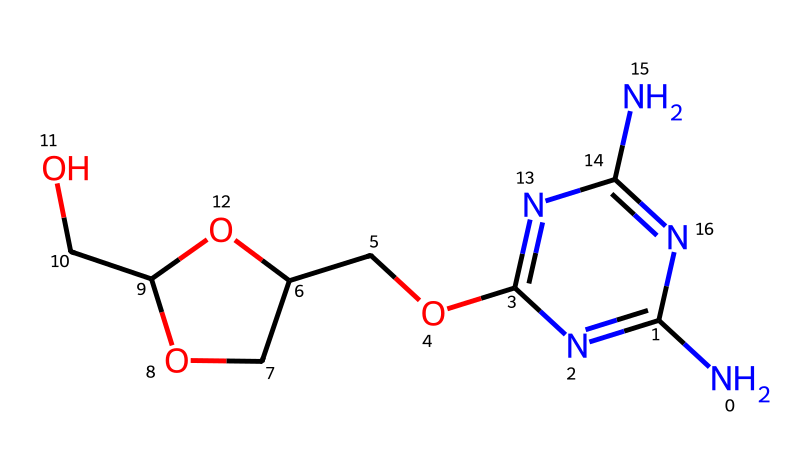What is the molecular formula of this compound? To determine the molecular formula, we need to count the number of each type of atom in the SMILES representation. This compound has 10 carbon (C) atoms, 15 hydrogen (H) atoms, 6 nitrogen (N) atoms, and 3 oxygen (O) atoms. Therefore, the molecular formula is C10H15N6O3.
Answer: C10H15N6O3 How many nitrogen atoms are present in the structure? By analyzing the SMILES representation, we can identify there are six nitrogen atoms (N) present throughout the structure.
Answer: 6 What type of functional groups are indicated in this chemical? The SMILES representation shows a hydroxyl group (-OH) due to the presence of oxygen and hydrogen in the structure, as well as amino groups (-NH2) indicated by nitrogen atoms connected to carbon.
Answer: hydroxyl and amino groups Does this compound likely demonstrate antiviral activity? The presence of multiple nitrogen atoms and specific structural arrangements may be indicative of pharmacological activity, particularly antiviral properties, common in molecules that interact with viral proteins or enzymes. However, experimental data is needed for confirmation.
Answer: likely What is the significance of the ether group present in this drug? The ether group contributes to the drug's overall solubility and bioavailability, affecting how the drug is distributed and utilized in biological systems, potentially impacting its effectiveness against viruses.
Answer: solubility and bioavailability Does this chemical structure suggest it may target RNA viruses specifically? The presence of multiple basic nitrogen atoms may enhance interactions with RNA viruses, which often rely on nucleic acids for replication, although more specific structural analysis and studies are required for conclusions.
Answer: yes, likely 